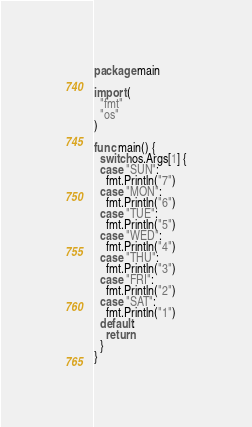Convert code to text. <code><loc_0><loc_0><loc_500><loc_500><_Go_>package main

import (
  "fmt"
  "os"
)

func main() {
  switch os.Args[1] {
  case "SUN":
    fmt.Println("7")
  case "MON":
    fmt.Println("6")
  case "TUE":
    fmt.Println("5")
  case "WED":
    fmt.Println("4")
  case "THU":
    fmt.Println("3")
  case "FRI":
    fmt.Println("2")
  case "SAT":
    fmt.Println("1")
  default:
    return
  }
}</code> 